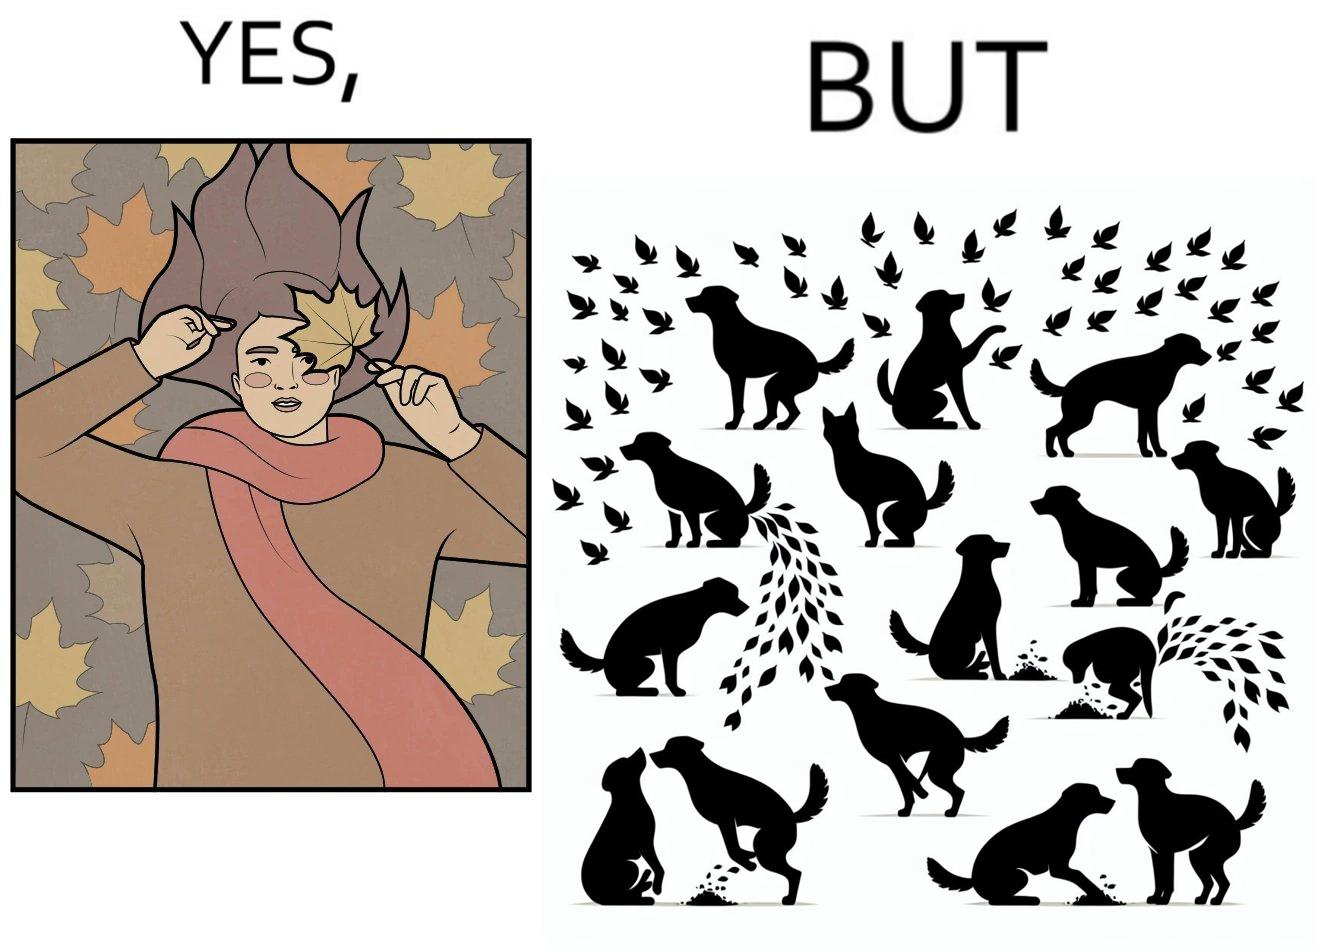Why is this image considered satirical? The images are funny since it show a woman holding a leaf over half of her face for a good photo but unknown to her is thale fact the same leaf might have been defecated or urinated upon by dogs and other wild animals 